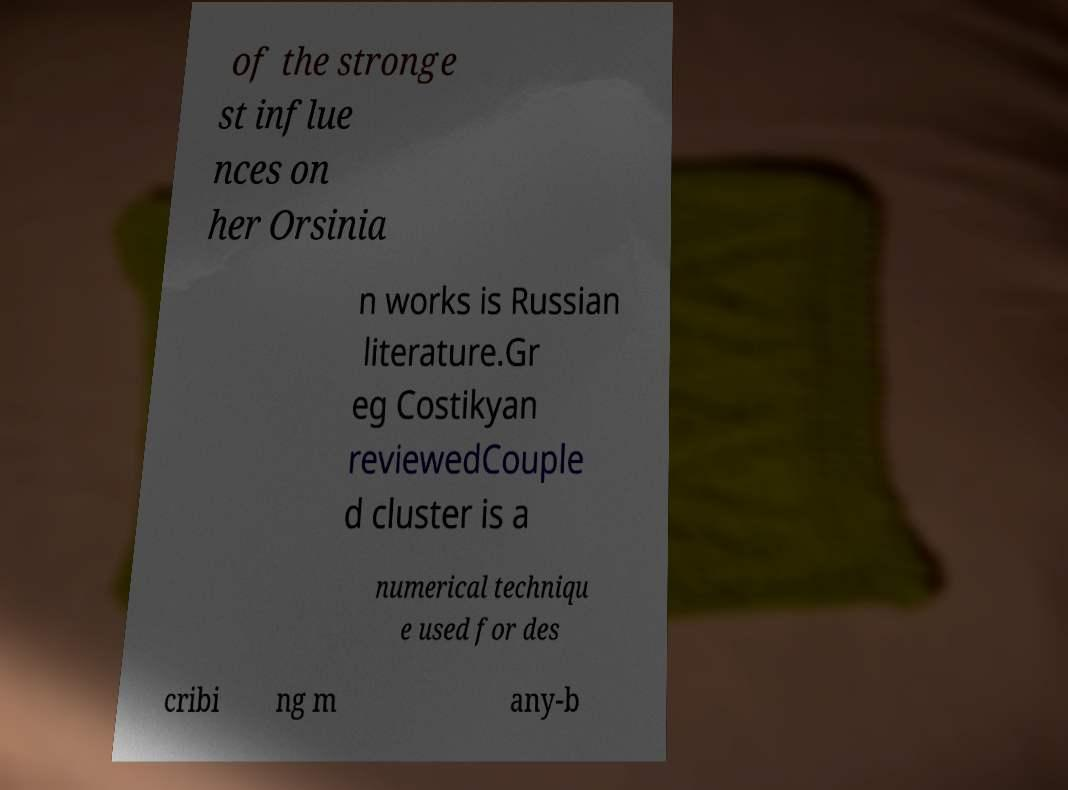Could you assist in decoding the text presented in this image and type it out clearly? of the stronge st influe nces on her Orsinia n works is Russian literature.Gr eg Costikyan reviewedCouple d cluster is a numerical techniqu e used for des cribi ng m any-b 